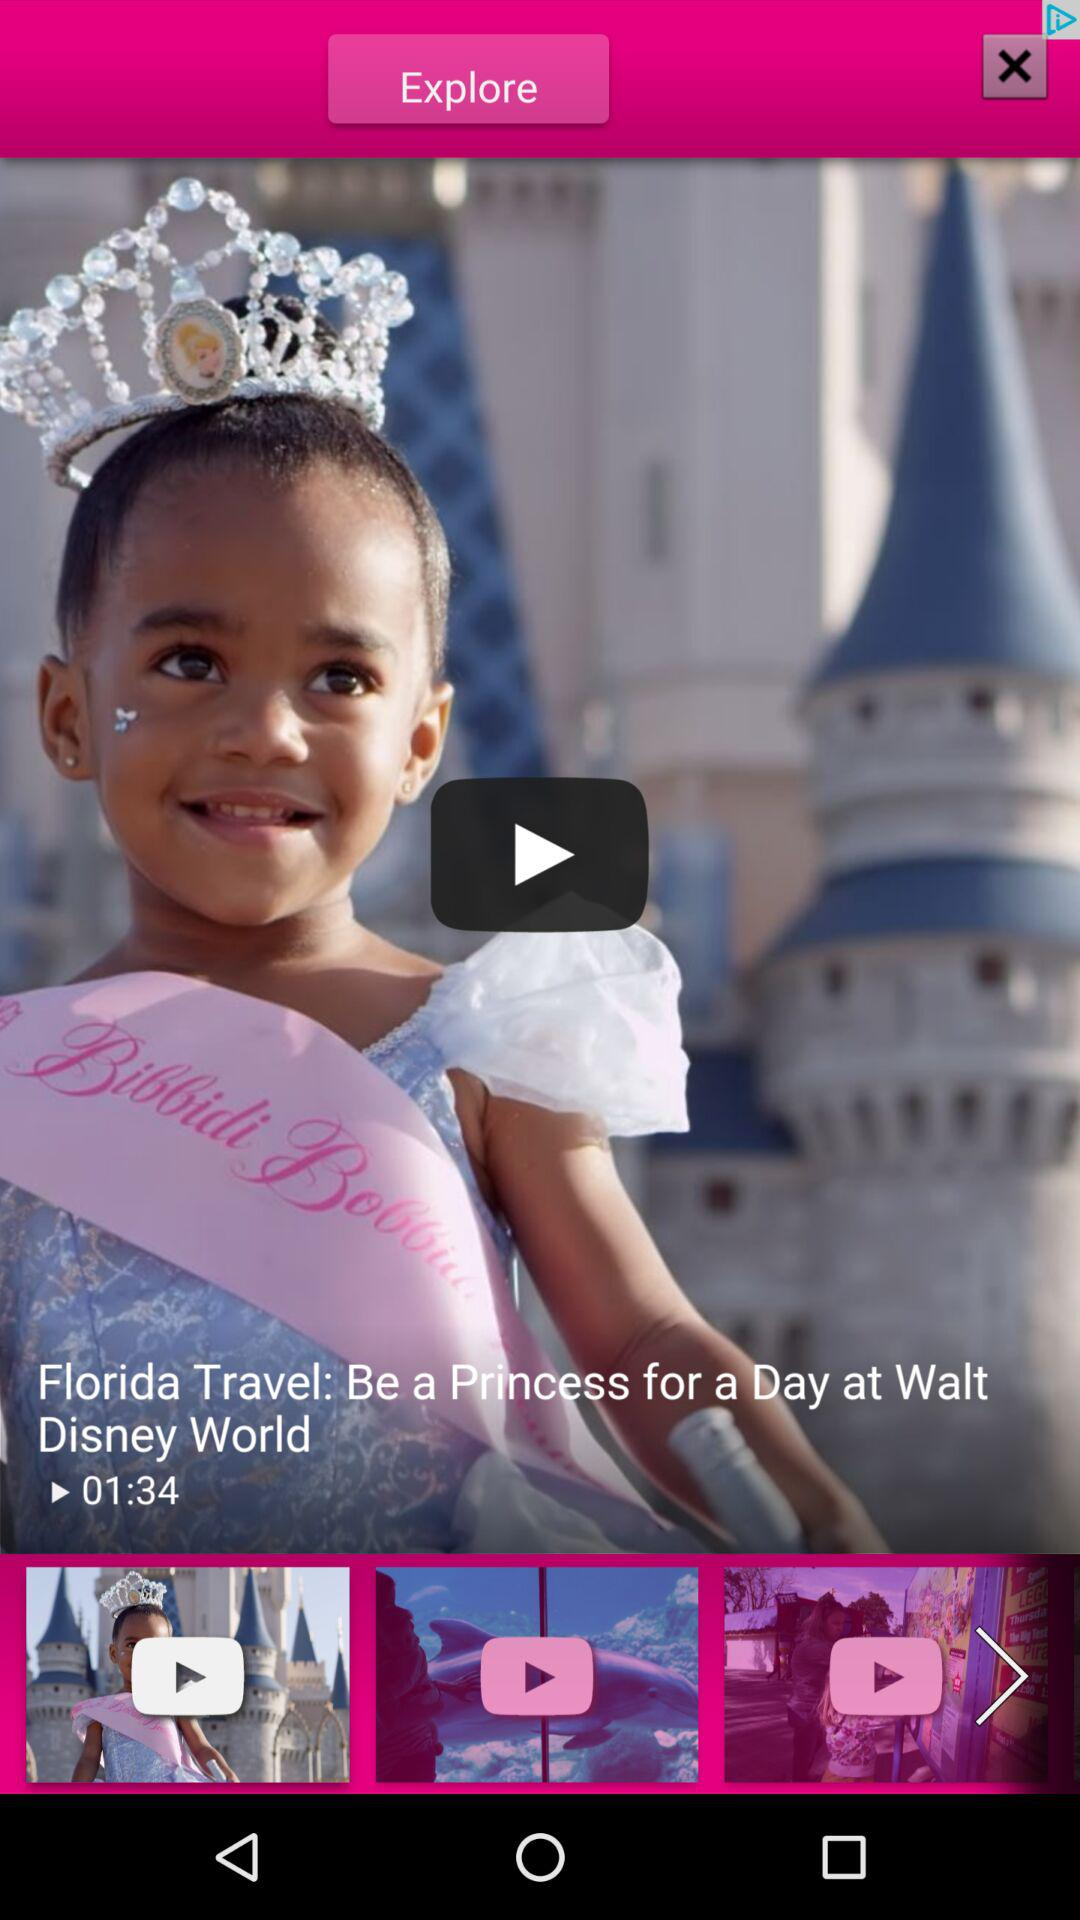What is the time duration of the video "Florida Travel"? The time duration is 1 minute 34 seconds. 